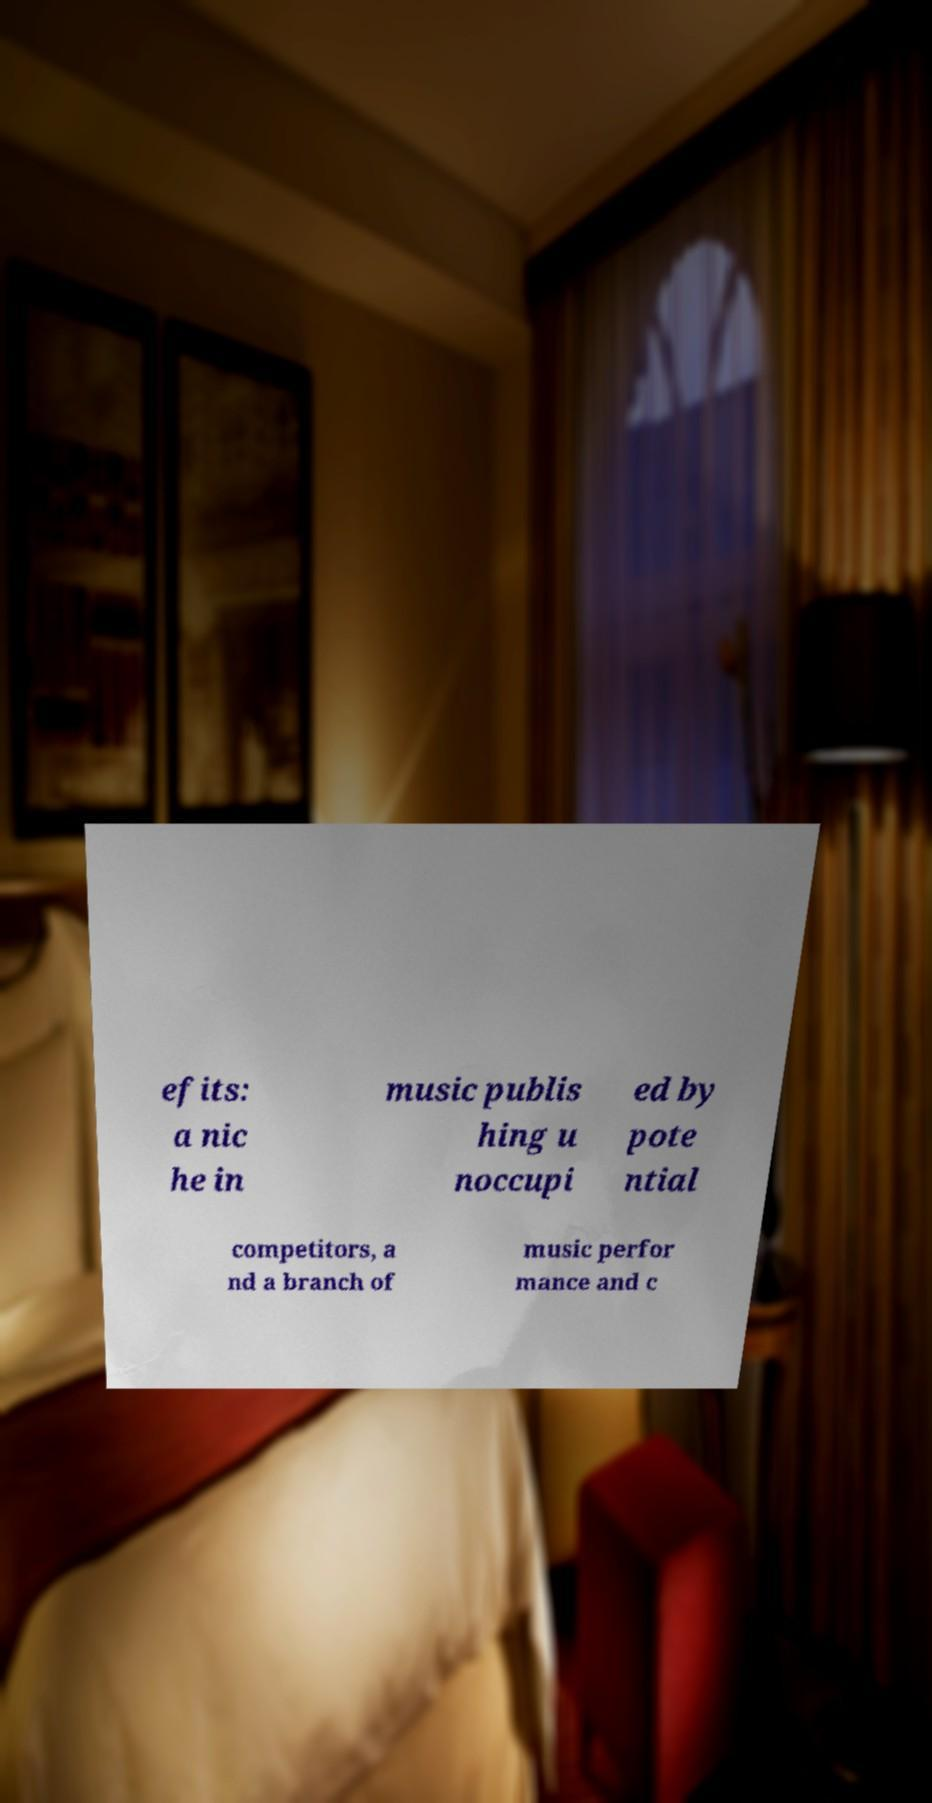Can you accurately transcribe the text from the provided image for me? efits: a nic he in music publis hing u noccupi ed by pote ntial competitors, a nd a branch of music perfor mance and c 